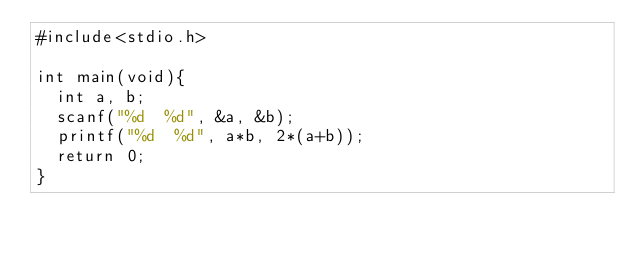<code> <loc_0><loc_0><loc_500><loc_500><_C_>#include<stdio.h>

int main(void){
	int a, b;
	scanf("%d  %d", &a, &b);
	printf("%d  %d", a*b, 2*(a+b));
	return 0;
}</code> 